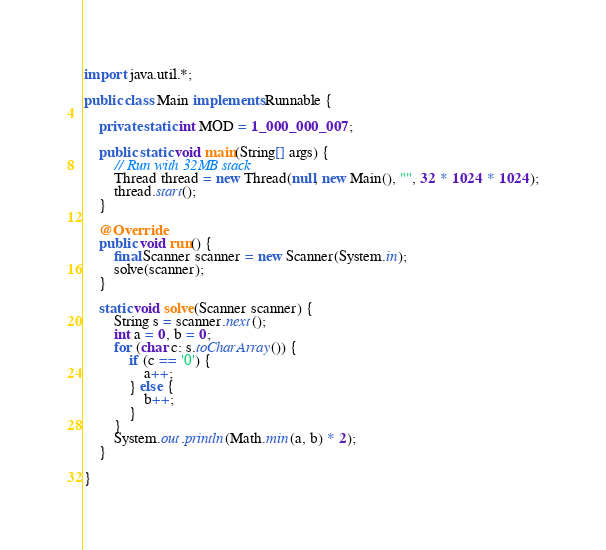<code> <loc_0><loc_0><loc_500><loc_500><_Java_>import java.util.*;

public class Main implements Runnable {

    private static int MOD = 1_000_000_007;

    public static void main(String[] args) {
        // Run with 32MB stack
        Thread thread = new Thread(null, new Main(), "", 32 * 1024 * 1024);
        thread.start();
    }

    @Override
    public void run() {
        final Scanner scanner = new Scanner(System.in);
        solve(scanner);
    }

    static void solve(Scanner scanner) {
        String s = scanner.next();
        int a = 0, b = 0;
        for (char c: s.toCharArray()) {
            if (c == '0') {
                a++;
            } else {
                b++;
            }
        }
        System.out.println(Math.min(a, b) * 2);
    }

}

</code> 